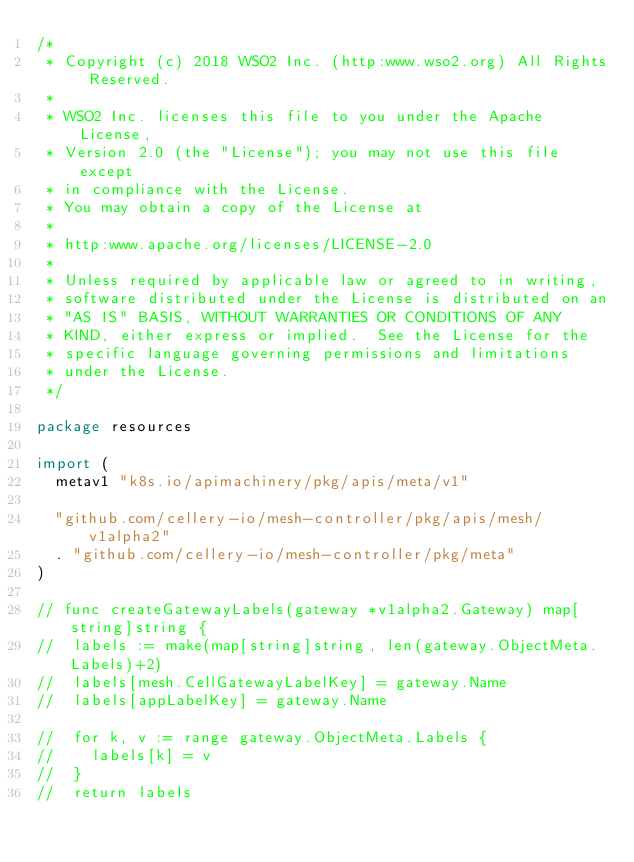Convert code to text. <code><loc_0><loc_0><loc_500><loc_500><_Go_>/*
 * Copyright (c) 2018 WSO2 Inc. (http:www.wso2.org) All Rights Reserved.
 *
 * WSO2 Inc. licenses this file to you under the Apache License,
 * Version 2.0 (the "License"); you may not use this file except
 * in compliance with the License.
 * You may obtain a copy of the License at
 *
 * http:www.apache.org/licenses/LICENSE-2.0
 *
 * Unless required by applicable law or agreed to in writing,
 * software distributed under the License is distributed on an
 * "AS IS" BASIS, WITHOUT WARRANTIES OR CONDITIONS OF ANY
 * KIND, either express or implied.  See the License for the
 * specific language governing permissions and limitations
 * under the License.
 */

package resources

import (
	metav1 "k8s.io/apimachinery/pkg/apis/meta/v1"

	"github.com/cellery-io/mesh-controller/pkg/apis/mesh/v1alpha2"
	. "github.com/cellery-io/mesh-controller/pkg/meta"
)

// func createGatewayLabels(gateway *v1alpha2.Gateway) map[string]string {
// 	labels := make(map[string]string, len(gateway.ObjectMeta.Labels)+2)
// 	labels[mesh.CellGatewayLabelKey] = gateway.Name
// 	labels[appLabelKey] = gateway.Name

// 	for k, v := range gateway.ObjectMeta.Labels {
// 		labels[k] = v
// 	}
// 	return labels</code> 